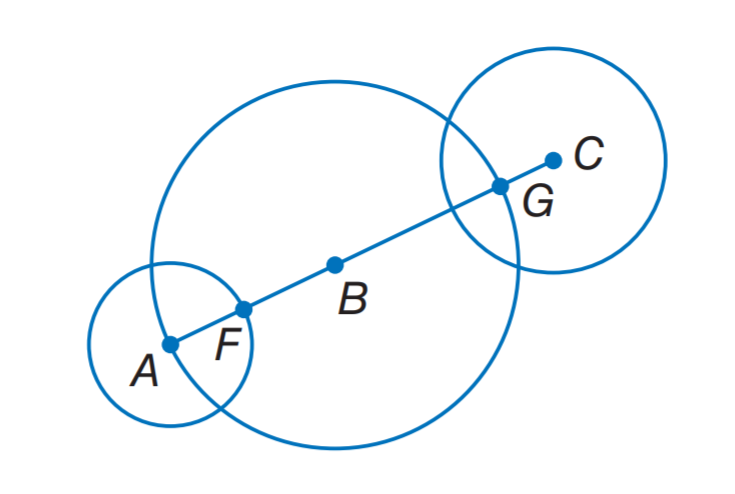Answer the mathemtical geometry problem and directly provide the correct option letter.
Question: The diameters of \odot A, \odot B, and \odot C are 8 inches, 18 inches, and 11 inches, respectively. Find F G.
Choices: A: 7 B: 8 C: 14 D: 16 C 